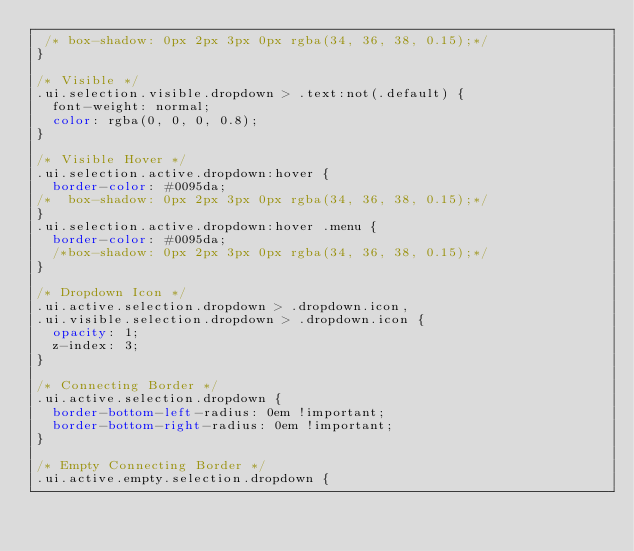Convert code to text. <code><loc_0><loc_0><loc_500><loc_500><_CSS_> /* box-shadow: 0px 2px 3px 0px rgba(34, 36, 38, 0.15);*/
}

/* Visible */
.ui.selection.visible.dropdown > .text:not(.default) {
  font-weight: normal;
  color: rgba(0, 0, 0, 0.8);
}

/* Visible Hover */
.ui.selection.active.dropdown:hover {
  border-color: #0095da;
/*  box-shadow: 0px 2px 3px 0px rgba(34, 36, 38, 0.15);*/
}
.ui.selection.active.dropdown:hover .menu {
  border-color: #0095da;
  /*box-shadow: 0px 2px 3px 0px rgba(34, 36, 38, 0.15);*/
}

/* Dropdown Icon */
.ui.active.selection.dropdown > .dropdown.icon,
.ui.visible.selection.dropdown > .dropdown.icon {
  opacity: 1;
  z-index: 3;
}

/* Connecting Border */
.ui.active.selection.dropdown {
  border-bottom-left-radius: 0em !important;
  border-bottom-right-radius: 0em !important;
}

/* Empty Connecting Border */
.ui.active.empty.selection.dropdown {</code> 